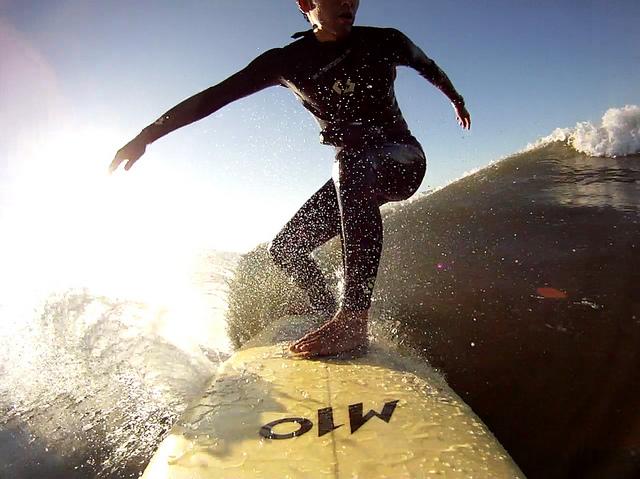What is written on the board?
Answer briefly. M10. What number is on the board?
Concise answer only. 10. What color is the board?
Short answer required. Yellow. 